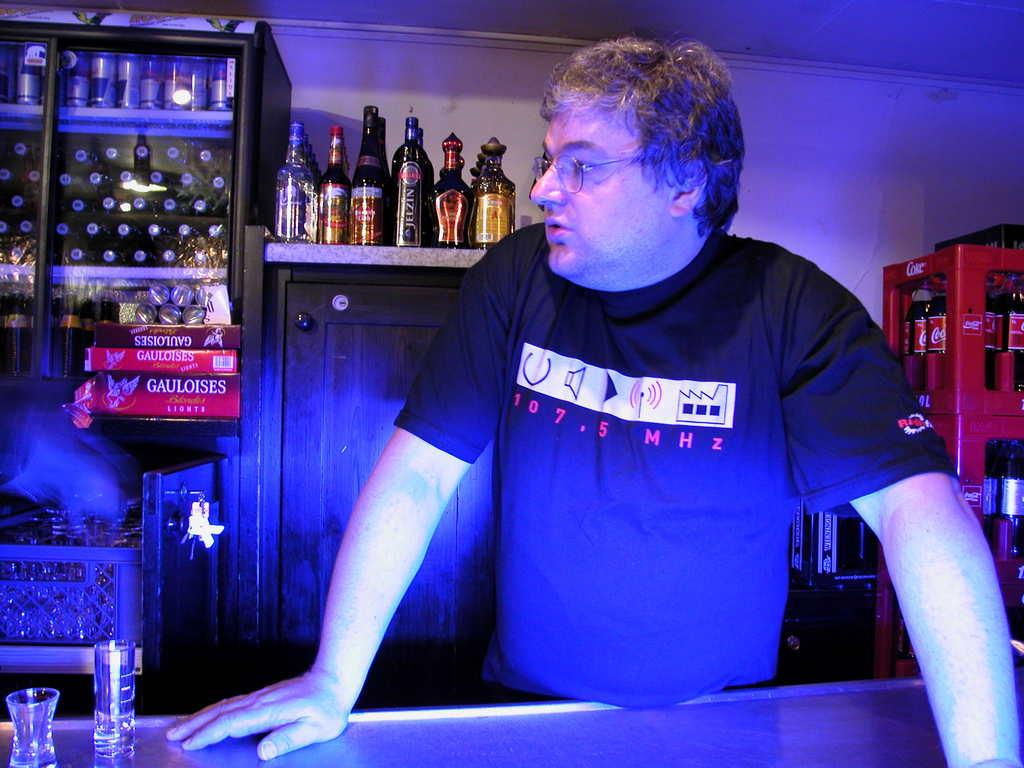<image>
Offer a succinct explanation of the picture presented. Man standing at a bar with a shirt reading 107.5 Mhz 